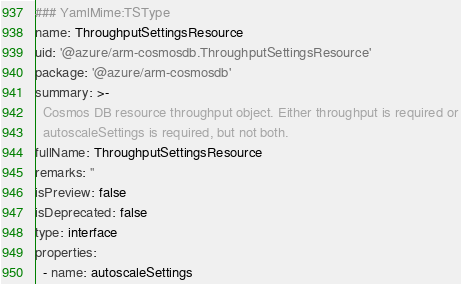<code> <loc_0><loc_0><loc_500><loc_500><_YAML_>### YamlMime:TSType
name: ThroughputSettingsResource
uid: '@azure/arm-cosmosdb.ThroughputSettingsResource'
package: '@azure/arm-cosmosdb'
summary: >-
  Cosmos DB resource throughput object. Either throughput is required or
  autoscaleSettings is required, but not both.
fullName: ThroughputSettingsResource
remarks: ''
isPreview: false
isDeprecated: false
type: interface
properties:
  - name: autoscaleSettings</code> 